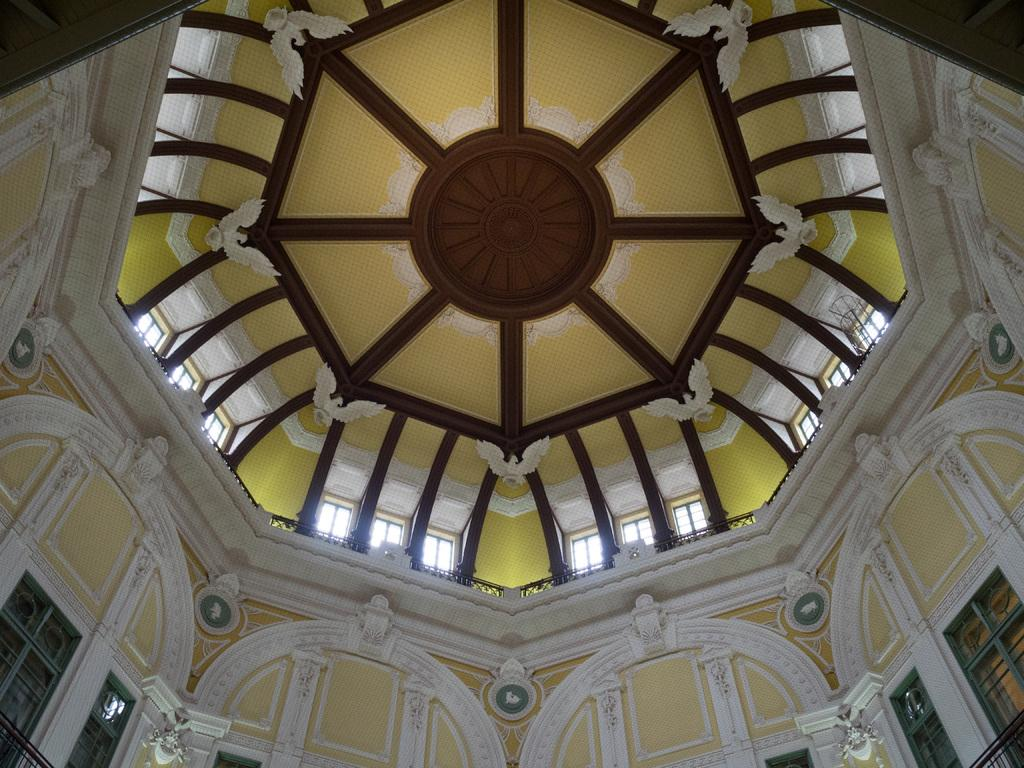What is present on top of the structure in the image? There is a roof in the image. What can be seen on the roof? The roof has sculptures. What are some ways to enter or exit the structure in the image? There are doors in the image. How can natural light enter the structure in the image? There are windows in the image. Can you see the hair of the person standing next to the door in the image? There is no person present in the image, so it is not possible to see their hair. 